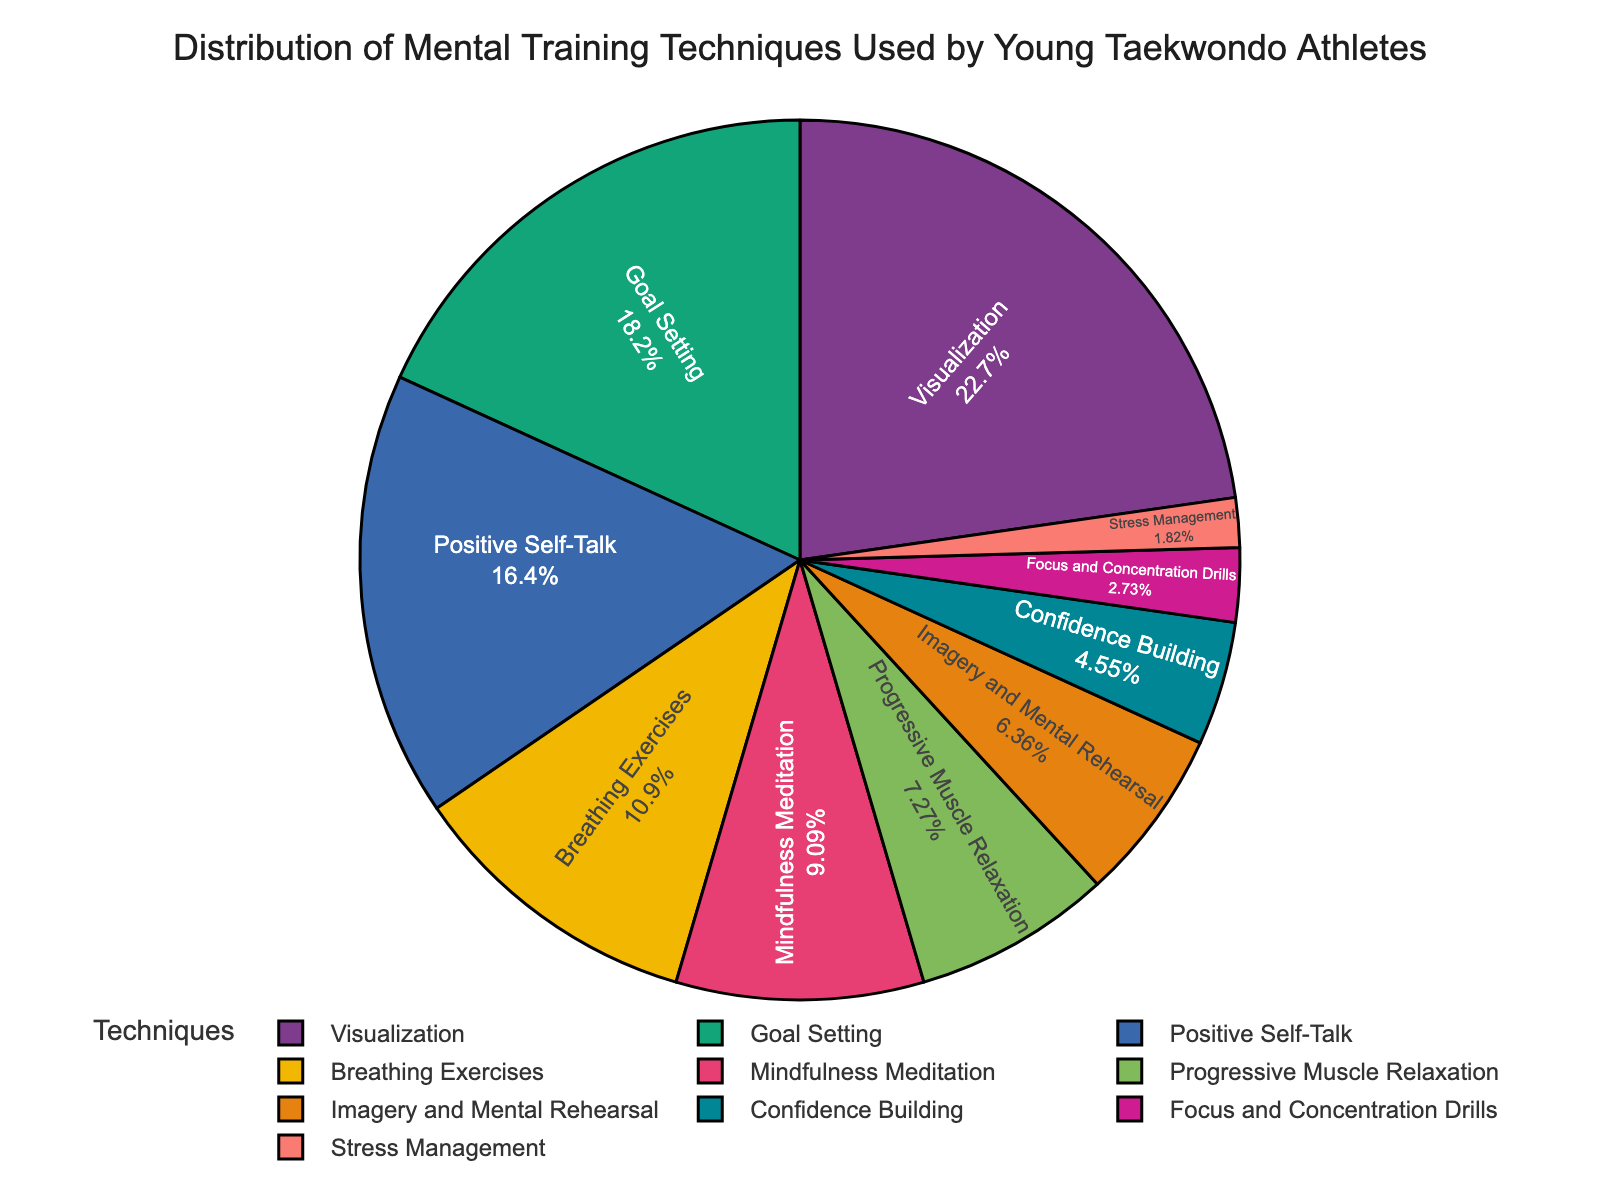What's the most commonly used mental training technique among young Taekwondo athletes? To find the most commonly used technique, look for the slice with the largest percentage. According to the figure, Visualization has the highest percentage, which is 25%.
Answer: Visualization Which technique has a larger percentage, Goal Setting or Positive Self-Talk? Compare the percentages of Goal Setting and Positive Self-Talk. Goal Setting has 20% while Positive Self-Talk has 18%. Therefore, Goal Setting has a larger percentage.
Answer: Goal Setting What's the combined percentage of Breathing Exercises and Mindfulness Meditation? Add the percentages of Breathing Exercises (12%) and Mindfulness Meditation (10%). 12% + 10% equals 22%.
Answer: 22% Are there more techniques with a percentage higher than 10% or techniques with a percentage lower than 10%? Count the techniques with percentages higher than 10%: Visualization (25%), Goal Setting (20%), Positive Self-Talk (18%), Breathing Exercises (12%), and Mindfulness Meditation (10%)—which are 5 techniques. Now count those with percentages lower than 10%: Progressive Muscle Relaxation (8%), Imagery and Mental Rehearsal (7%), Confidence Building (5%), Focus and Concentration Drills (3%), and Stress Management (2%)—which are also 5 techniques. Therefore, the number is equal.
Answer: Equal How many techniques fall within the 5-10% range? Identify and count the techniques whose percentages fall between 5% and 10%: Progressive Muscle Relaxation (8%), Imagery and Mental Rehearsal (7%), and Confidence Building (5%). Thus, there are 3 techniques.
Answer: 3 Which technique represents the smallest percentage and what is that percentage? Locate the slice with the smallest percentage in the pie chart. Stress Management has the smallest percentage, which is 2%.
Answer: Stress Management with 2% What's the difference in percentage between the most and least used techniques? Subtract the smallest percentage from the largest percentage. The largest is 25% (Visualization) and the smallest is 2% (Stress Management). The difference is 25% - 2% = 23%.
Answer: 23% Between Imagery and Mental Rehearsal and Breathing Exercises, which technique is used less and by how much? Compare the percentages of Imagery and Mental Rehearsal (7%) and Breathing Exercises (12%). Imagery and Mental Rehearsal is used less by (12% - 7%) = 5%.
Answer: Imagery and Mental Rehearsal by 5% What's the total percentage of the top three techniques combined? Add the percentages of the top three techniques: Visualization (25%), Goal Setting (20%), and Positive Self-Talk (18%). 25% + 20% + 18% = 63%.
Answer: 63% Which techniques cover approximately 30% of the distribution, and what are their exact percentages? Look for a combination of techniques that approximately sum up to 30%. Breathing Exercises (12%), Mindfulness Meditation (10%), and Progressive Muscle Relaxation (8%) together make 12% + 10% + 8% = 30%.
Answer: Breathing Exercises, Mindfulness Meditation, Progressive Muscle Relaxation with 12%, 10%, 8% respectively 